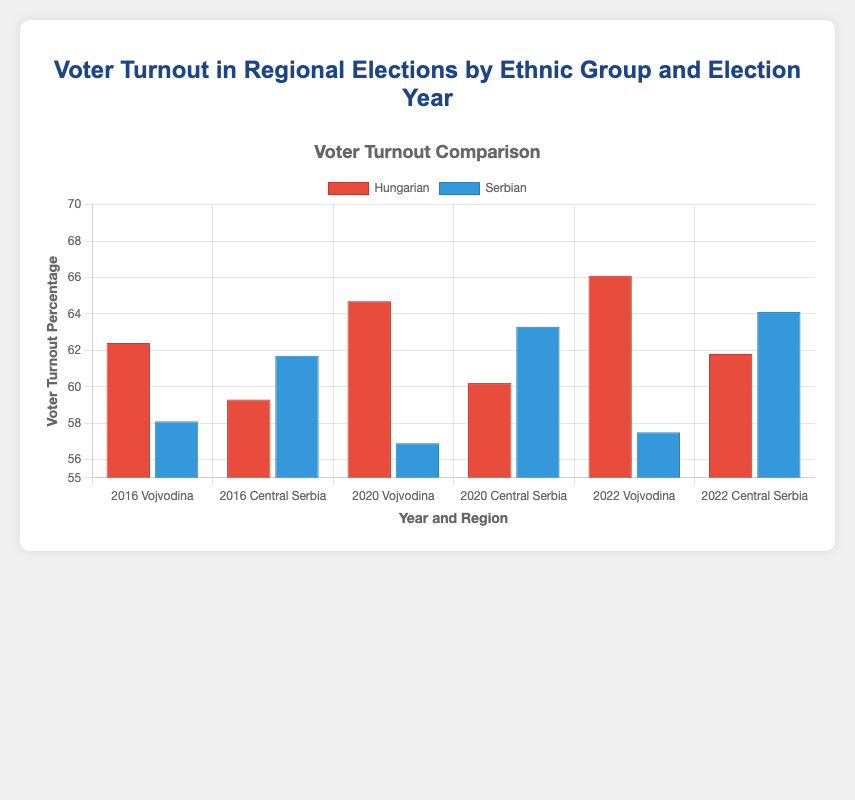What is the voter turnout percentage for the Hungarian ethnic group in Vojvodina in 2020? To find the voter turnout percentage for the Hungarian ethnic group in Vojvodina in 2020, look for the bar corresponding to the Hungarian group in Vojvodina under the year 2020.
Answer: 64.7% Which ethnic group had a higher voter turnout in Central Serbia in 2016? Compare the voter turnout percentages for the Hungarian and Serbian groups in Central Serbia in 2016. The Serbian percentage is higher.
Answer: Serbian What is the difference in voter turnout percentage between the Hungarian ethnic group in Vojvodina in 2020 and Central Serbia in 2020? Subtract the voter turnout percentage for the Hungarian ethnic group in Central Serbia in 2020 (60.2%) from that in Vojvodina (64.7%).
Answer: 4.5% In which year did the Hungarian ethnic group in Vojvodina experience the highest voter turnout? Compare the voter turnout percentages of the Hungarian ethnic group in Vojvodina across all years (2016, 2020, 2022) and determine the highest value.
Answer: 2022 Did the voter turnout for the Serbian ethnic group in Central Serbia increase or decrease from 2020 to 2022? Compare the voter turnout percentages for the Serbian ethnic group in Central Serbia between the years 2020 and 2022. It increased from 63.3% to 64.1%.
Answer: Increase What is the average voter turnout percentage for the Hungarian ethnic group across all regions and years provided? Sum the voter turnout percentages for the Hungarian ethnic group across all regions and years (62.4 + 59.3 + 64.7 + 60.2 + 66.1 + 61.8) and divide by the number of data points (6).
Answer: 62.42% Which region had the highest voter turnout for the Serbian ethnic group in 2020? Compare the voter turnout percentages for the Serbian ethnic group in Vojvodina and Central Serbia in 2020 and determine the highest value.
Answer: Central Serbia Is the voter turnout for the Serbian ethnic group higher in Vojvodina or Central Serbia in 2022? Compare the voter turnout percentages for the Serbian ethnic group in Vojvodina (57.5%) with Central Serbia (64.1%) and determine which is higher.
Answer: Central Serbia What is the combined voter turnout percentage for both ethnic groups in Vojvodina in 2016? Combine the voter turnout percentages for the Hungarian and Serbian groups in Vojvodina in 2016 (62.4% + 58.1%).
Answer: 120.5% Are the voter turnout percentages for the Hungarian ethnic group in Central Serbia generally increasing or decreasing from 2016 to 2022? Analyze the voter turnout percentages for the Hungarian ethnic group in Central Serbia from 2016 (59.3%) to 2020 (60.2%) to 2022 (61.8%) and observe the trend.
Answer: Increasing 